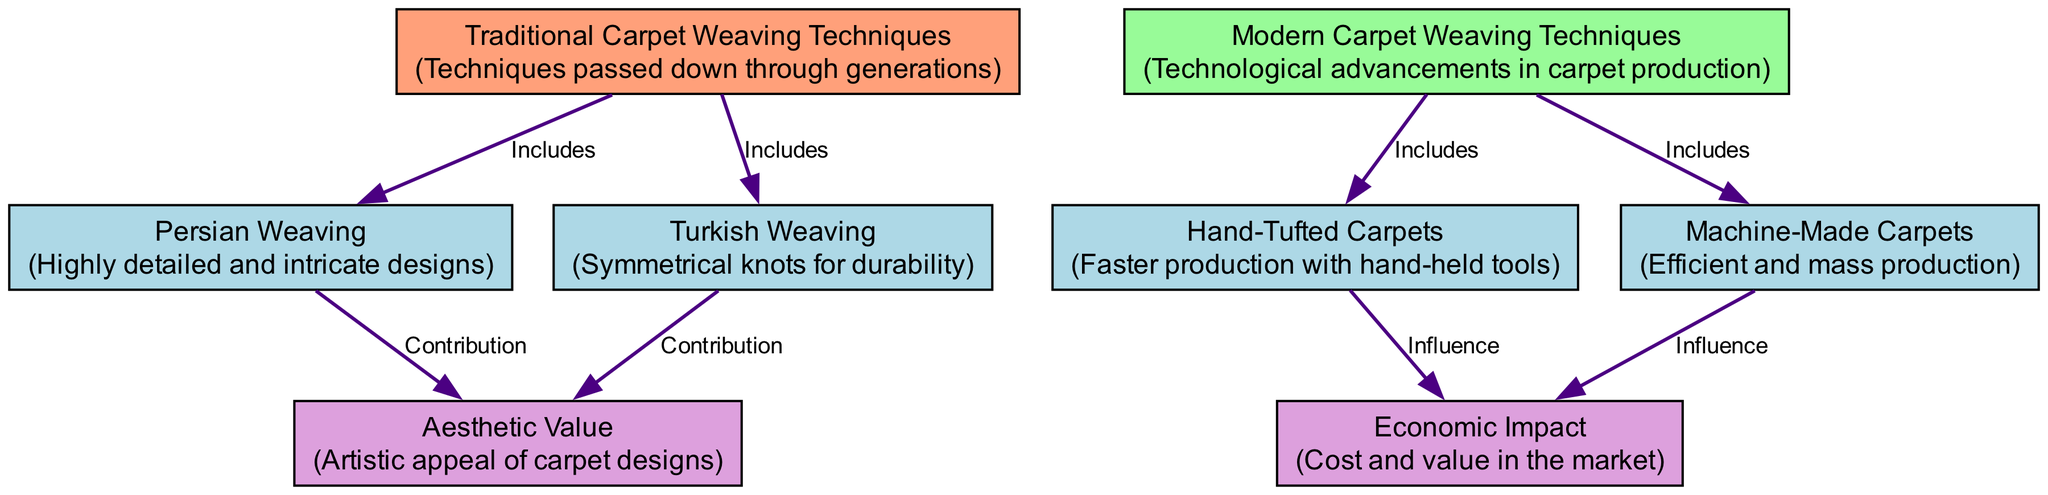What are the two main categories represented in the diagram? The diagram has two main categories at the top: "Traditional Carpet Weaving Techniques" and "Modern Carpet Weaving Techniques." These categories are the primary classifications of the weaving techniques.
Answer: Traditional Carpet Weaving Techniques, Modern Carpet Weaving Techniques How many specific techniques are included under traditional weaving? There are two specific techniques listed under traditional weaving: "Persian Weaving" and "Turkish Weaving," which are shown as descending nodes from "Traditional Carpet Weaving Techniques."
Answer: 2 Which modern technique is related to economic impact? The node "Hand-Tufted Carpets" is linked to "Economic Impact," indicating that this modern technique has an influence on economic factors in the carpet market.
Answer: Hand-Tufted Carpets What type of designs does Persian weaving contribute to? The diagram shows that "Persian Weaving" contributes to "Aesthetic Value," which refers to the artistic appeal and design qualities of carpets produced using this technique.
Answer: Aesthetic Value How many edges are associated with modern carpet weaving techniques? There are four edges that connect to the modern category nodes. Each modern technique ("Hand-Tufted Carpets" and "Machine-Made Carpets") has one edge leading to "Economic Impact," totaling four connections.
Answer: 4 What type of knot does Turkish weaving utilize for durability? The diagram indicates that "Turkish Weaving" utilizes "Symmetrical knots," emphasizing its traditional craftsmanship that focuses on creating durable carpets.
Answer: Symmetrical knots What unique contribution does machine-made carpet production make? "Machine-Made Carpets" influence the "Economic Impact," depicting their connection to a more efficient and mass-produced approach to carpet making, affecting market cost and value.
Answer: Economic Impact Which traditional weaving technique is described as having highly detailed designs? The node "Persian Weaving" specifies that it is characterized by "Highly detailed and intricate designs," distinguishing it from others within the traditional carpet weaving techniques.
Answer: Highly detailed and intricate designs 